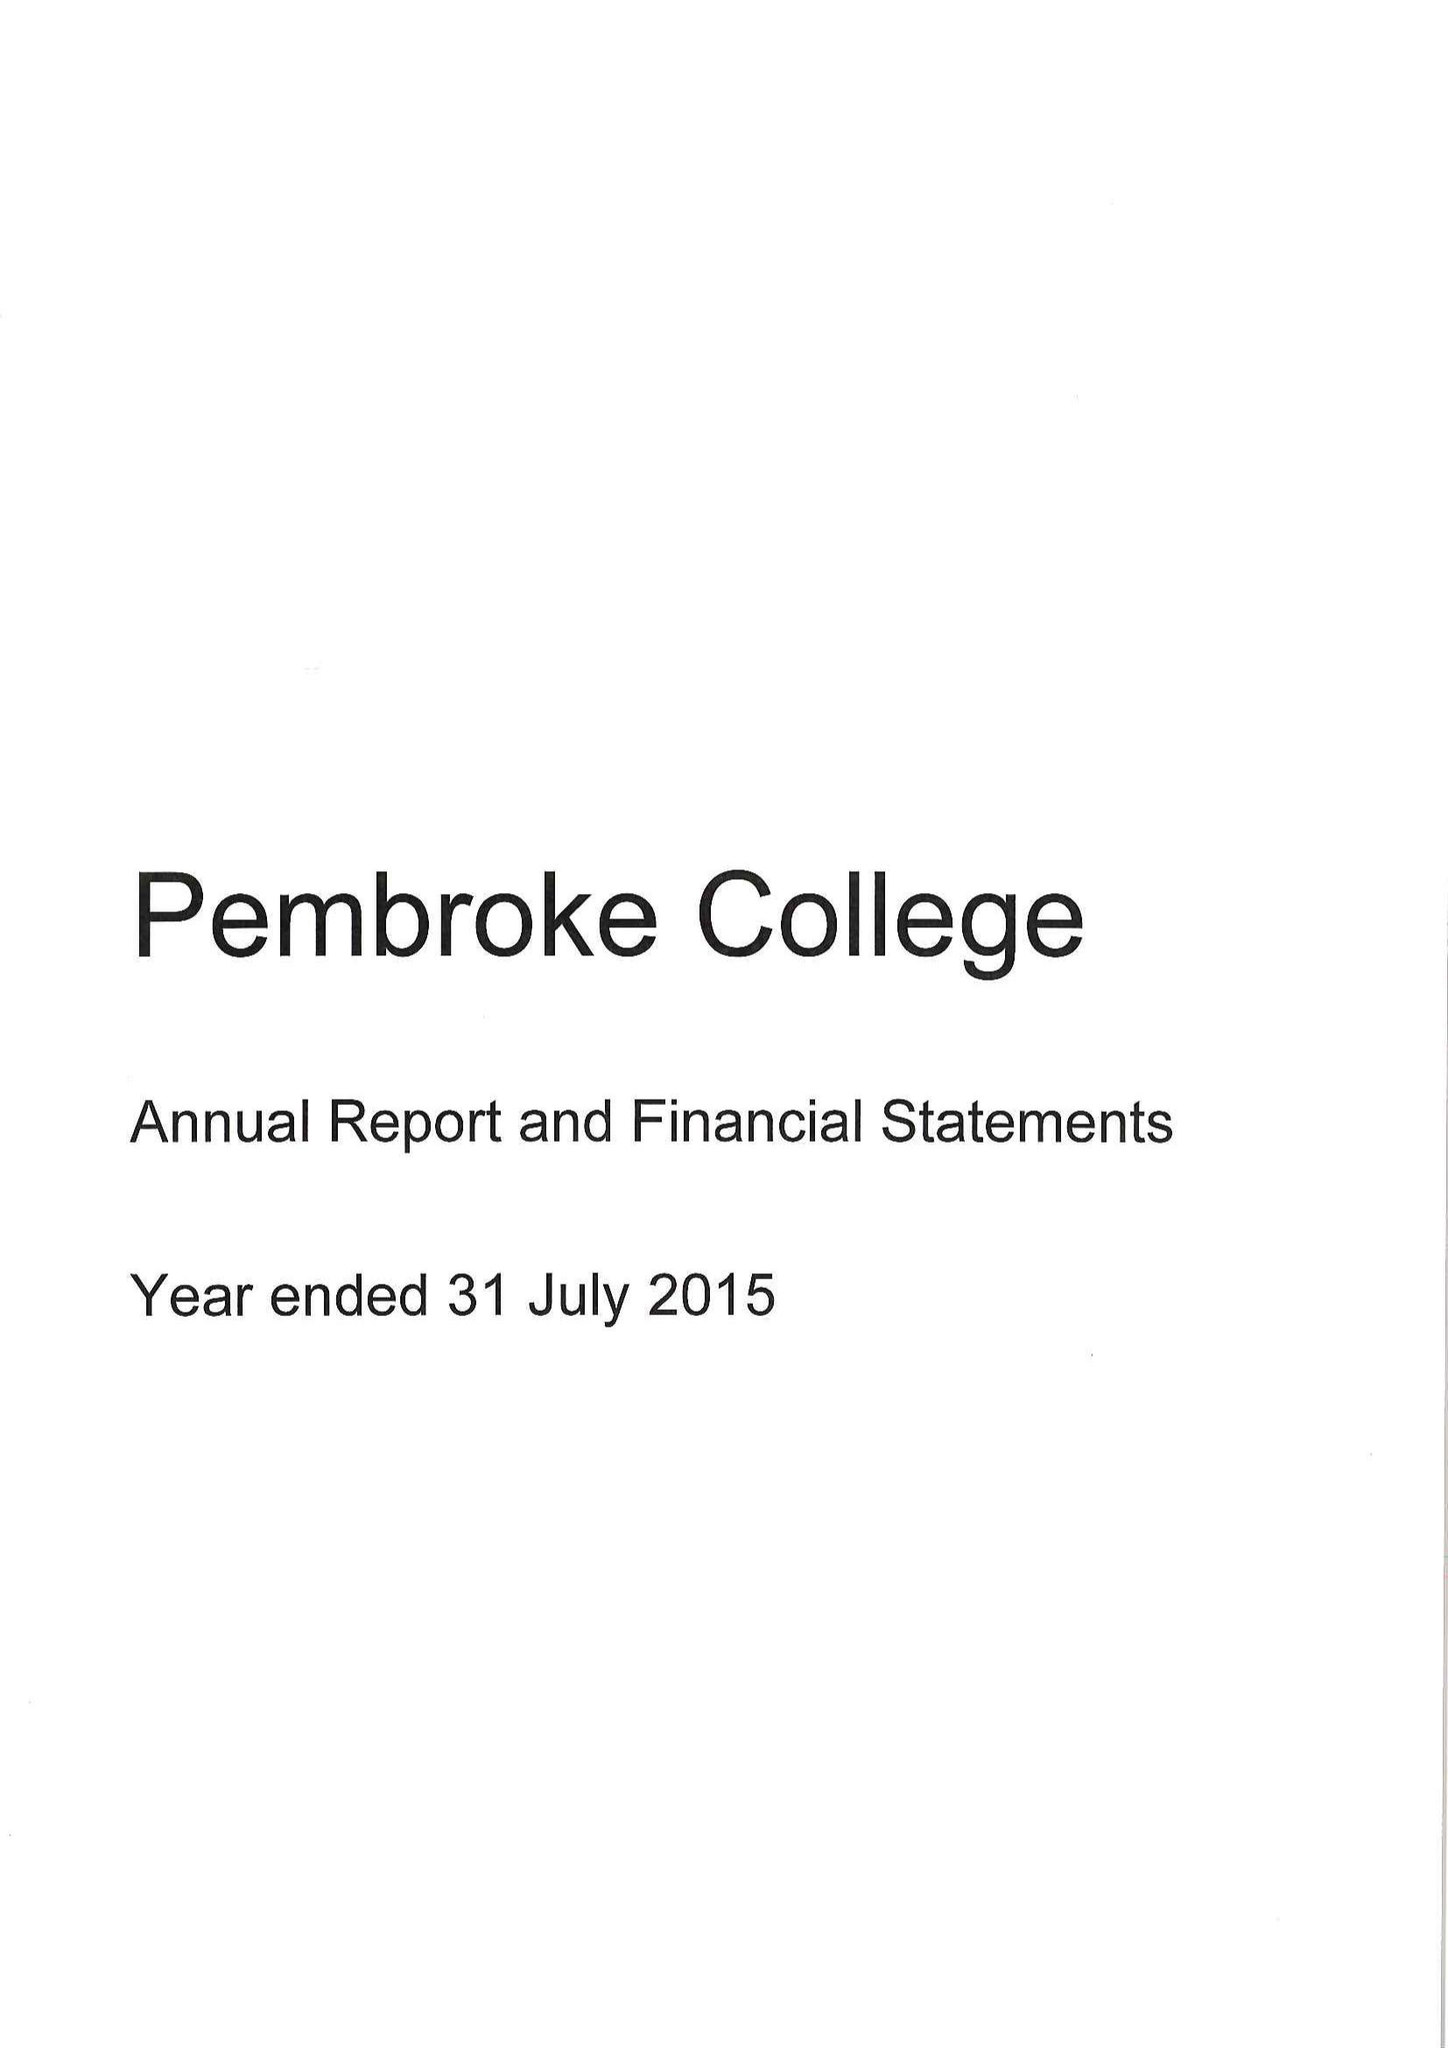What is the value for the charity_number?
Answer the question using a single word or phrase. 1137498 